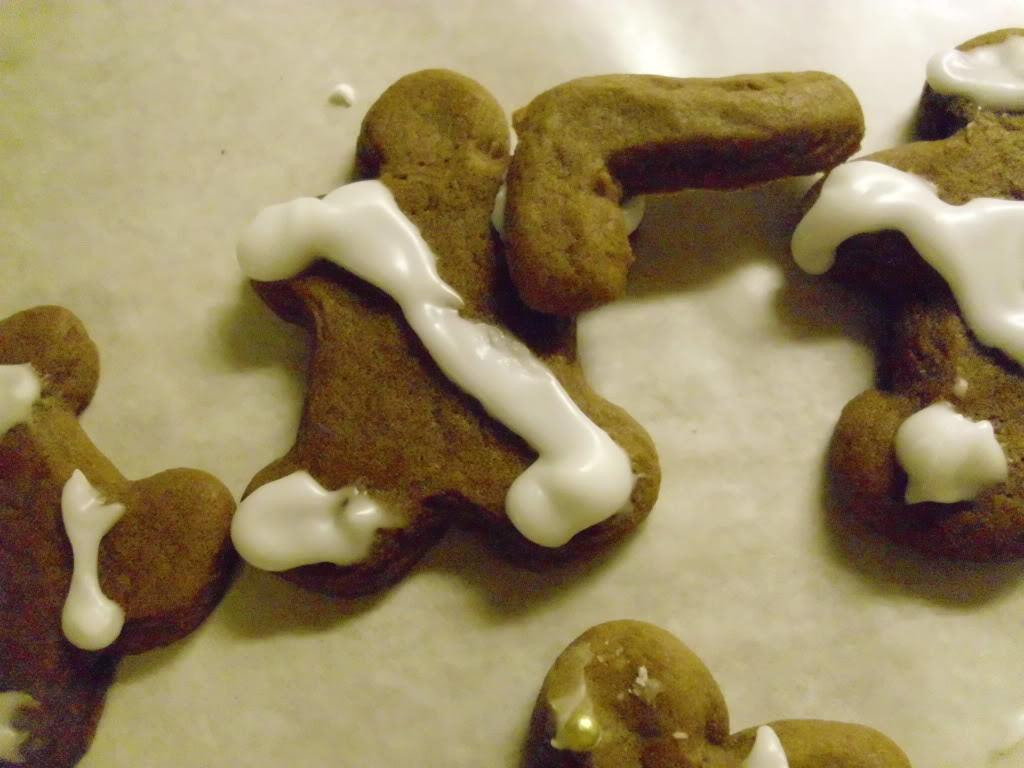What types of items can be seen in the image? There are food items in the image. Can you describe the object in the background of the image? There is an object that seems to be a platter in the background of the image. What type of legal advice can be obtained from the food items in the image? The food items in the image do not provide legal advice, as they are not a lawyer or a source of legal information. 